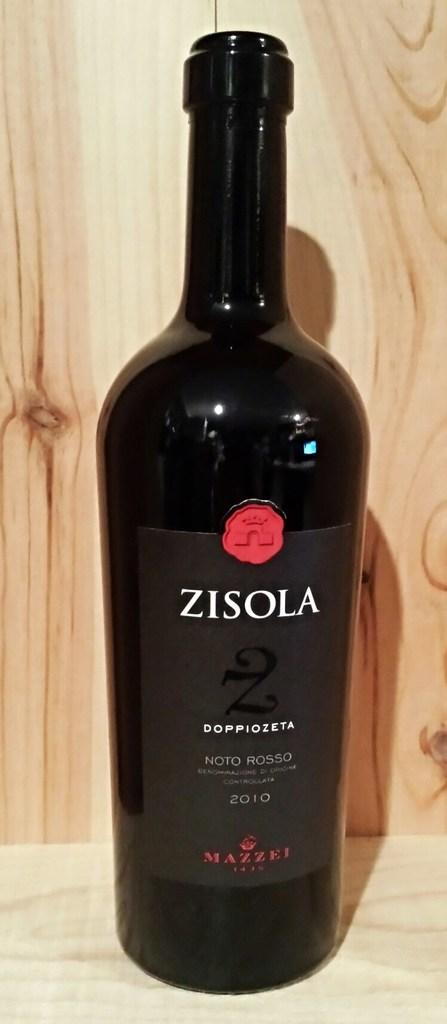<image>
Write a terse but informative summary of the picture. A black bottle of wine with red and white lettering. 